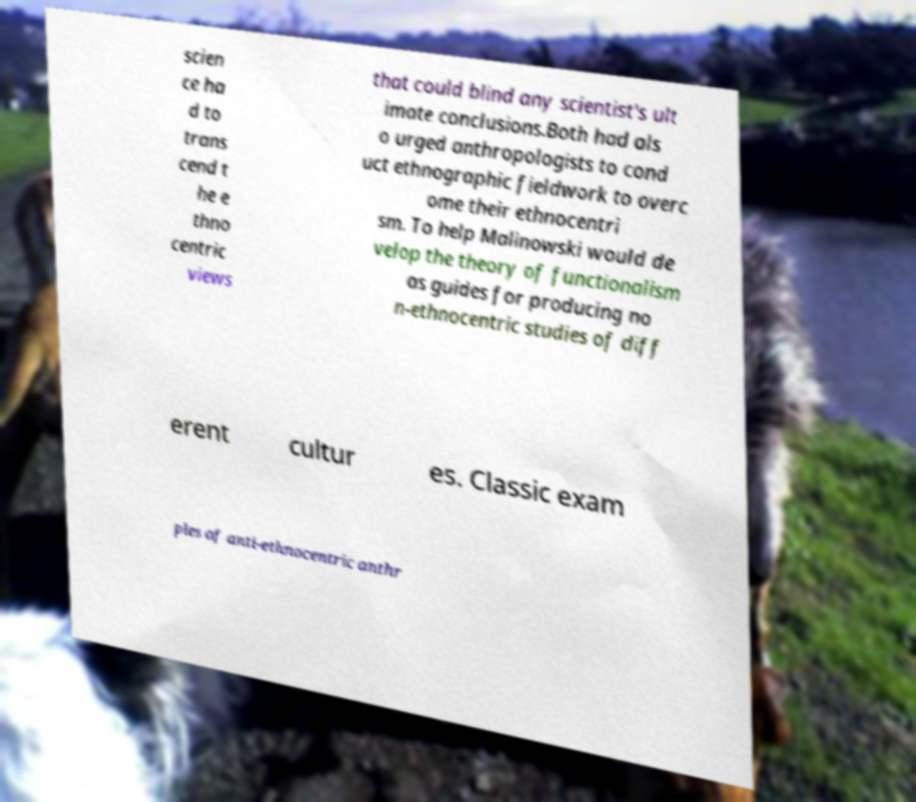I need the written content from this picture converted into text. Can you do that? scien ce ha d to trans cend t he e thno centric views that could blind any scientist's ult imate conclusions.Both had als o urged anthropologists to cond uct ethnographic fieldwork to overc ome their ethnocentri sm. To help Malinowski would de velop the theory of functionalism as guides for producing no n-ethnocentric studies of diff erent cultur es. Classic exam ples of anti-ethnocentric anthr 